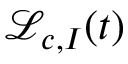Convert formula to latex. <formula><loc_0><loc_0><loc_500><loc_500>{ \mathcal { L } } _ { c , I } ( t )</formula> 